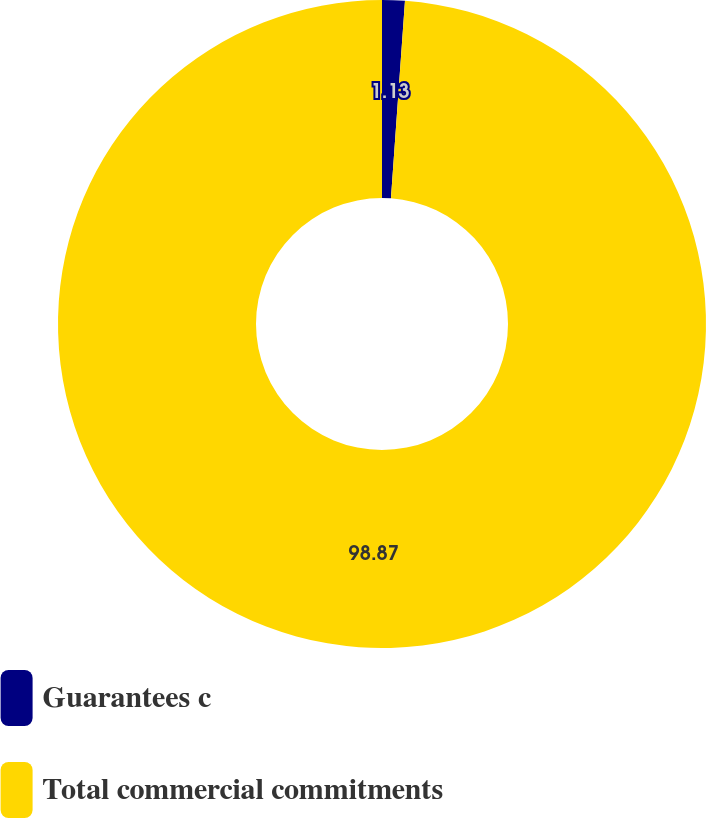Convert chart. <chart><loc_0><loc_0><loc_500><loc_500><pie_chart><fcel>Guarantees c<fcel>Total commercial commitments<nl><fcel>1.13%<fcel>98.87%<nl></chart> 